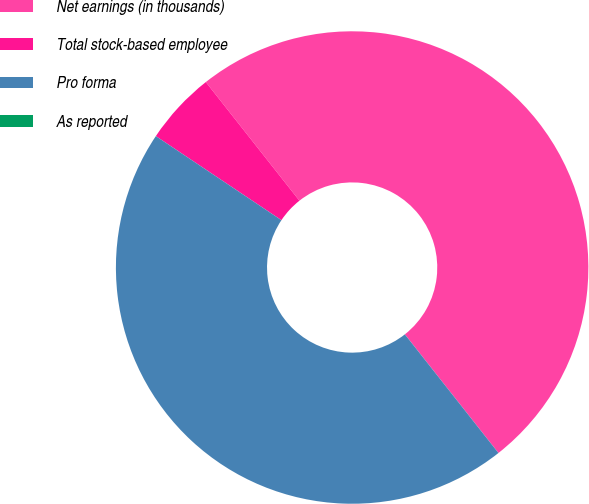<chart> <loc_0><loc_0><loc_500><loc_500><pie_chart><fcel>Net earnings (in thousands)<fcel>Total stock-based employee<fcel>Pro forma<fcel>As reported<nl><fcel>50.0%<fcel>4.98%<fcel>45.02%<fcel>0.0%<nl></chart> 